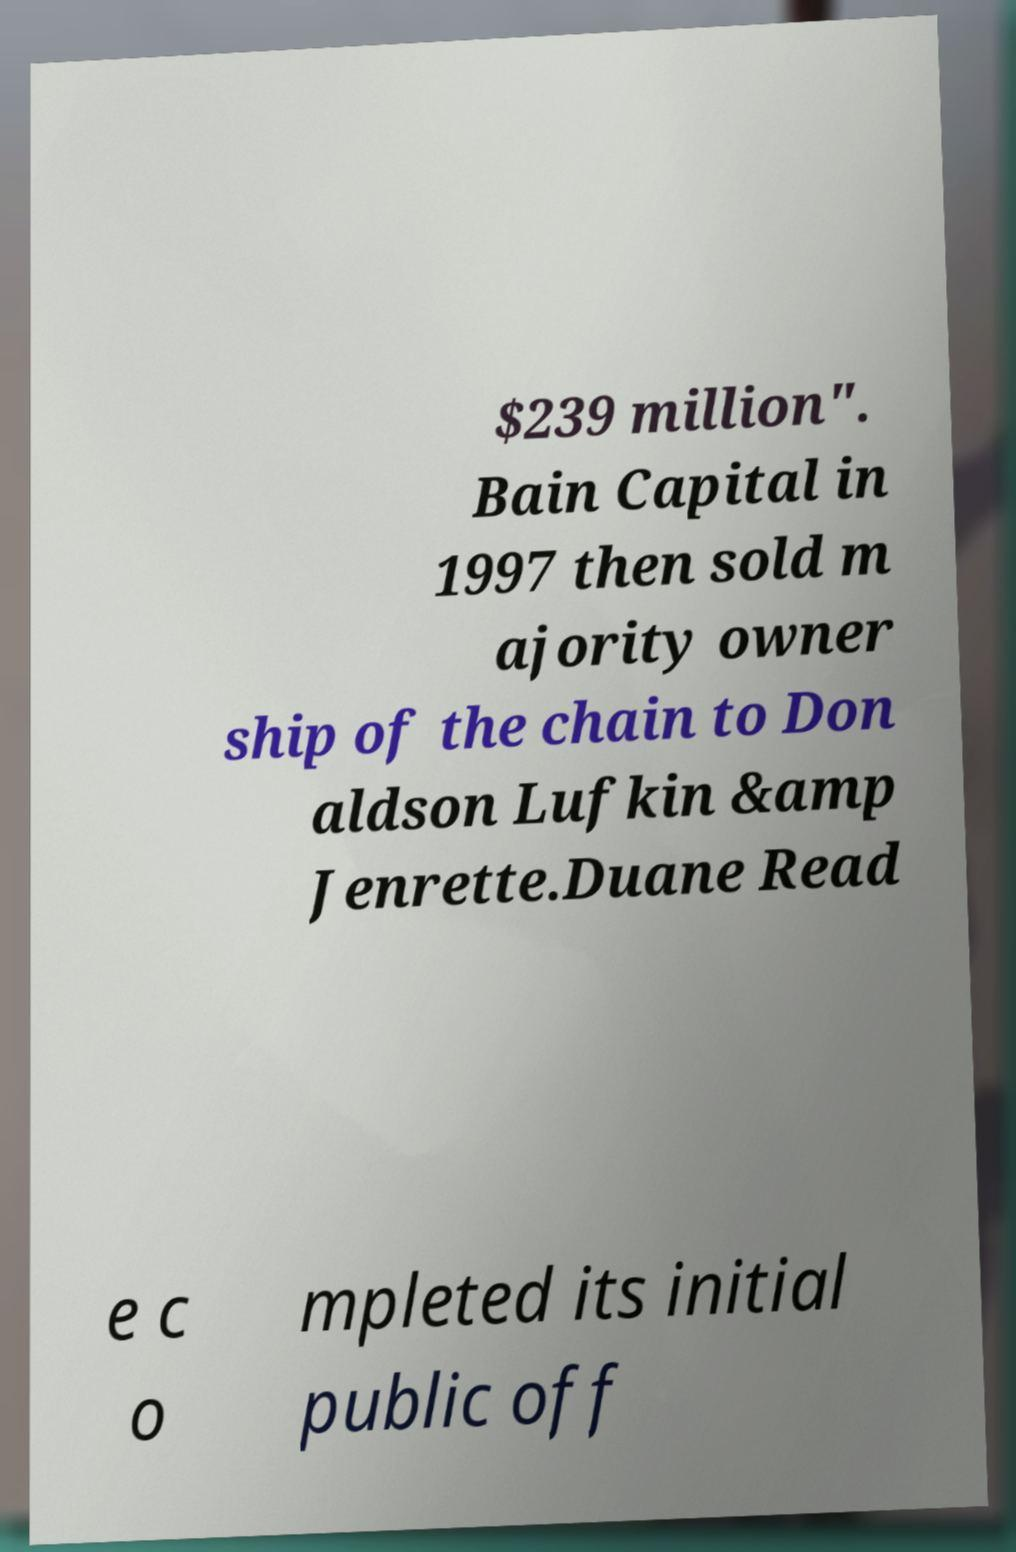I need the written content from this picture converted into text. Can you do that? $239 million". Bain Capital in 1997 then sold m ajority owner ship of the chain to Don aldson Lufkin &amp Jenrette.Duane Read e c o mpleted its initial public off 